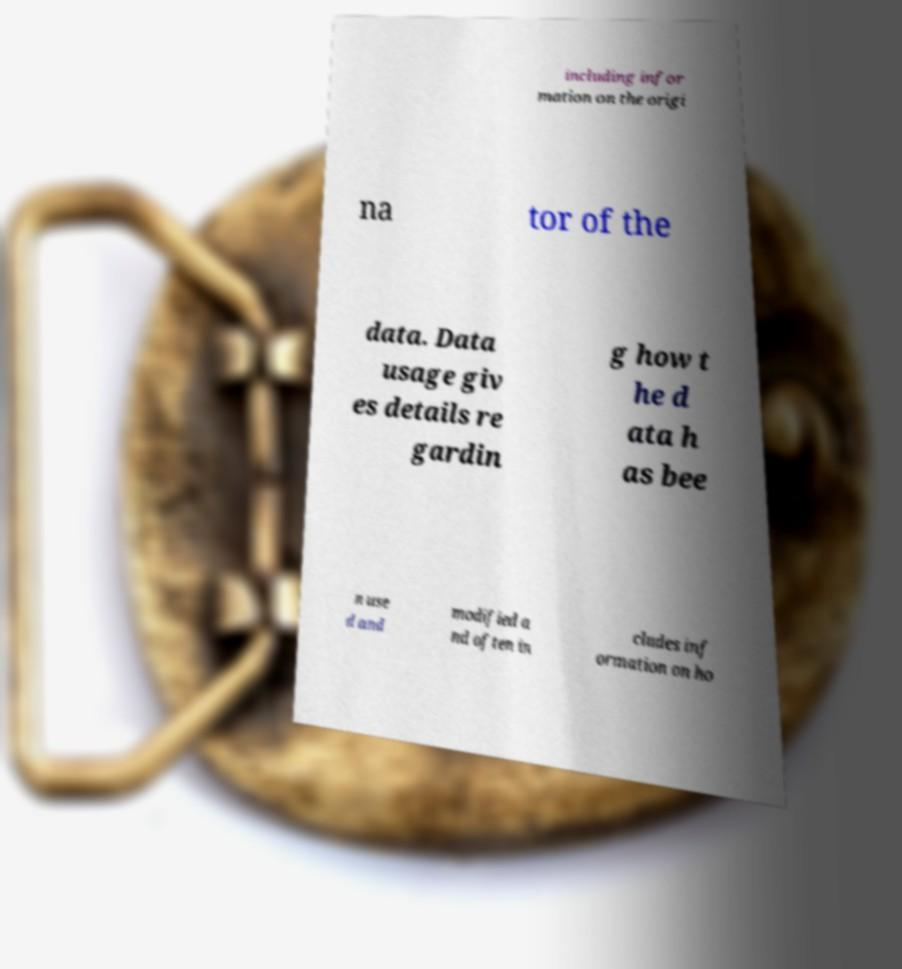Please read and relay the text visible in this image. What does it say? including infor mation on the origi na tor of the data. Data usage giv es details re gardin g how t he d ata h as bee n use d and modified a nd often in cludes inf ormation on ho 